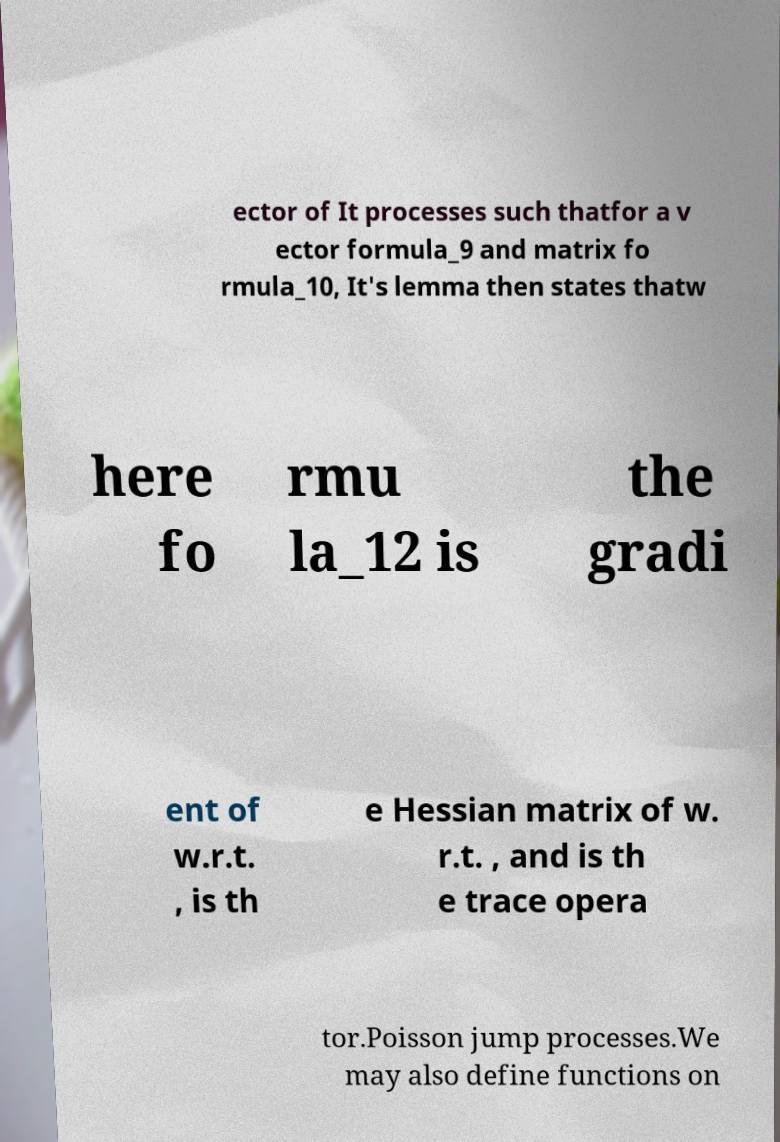Can you accurately transcribe the text from the provided image for me? ector of It processes such thatfor a v ector formula_9 and matrix fo rmula_10, It's lemma then states thatw here fo rmu la_12 is the gradi ent of w.r.t. , is th e Hessian matrix of w. r.t. , and is th e trace opera tor.Poisson jump processes.We may also define functions on 